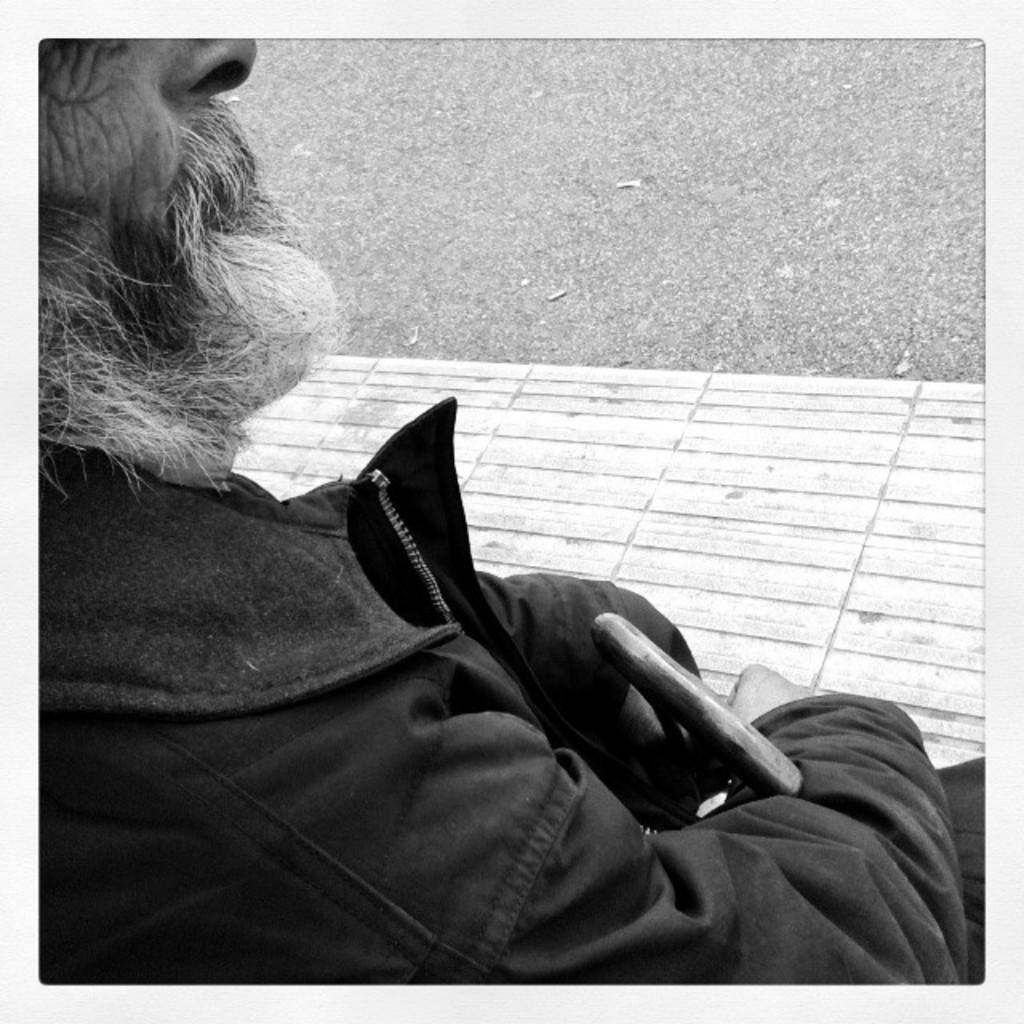What is present in the image? There is a person in the image. What is the person holding in his hand? The person is holding a walking stick in his hand. What language is the person speaking in the image? There is no indication of the person speaking in the image, so it cannot be determined which language they might be using. 